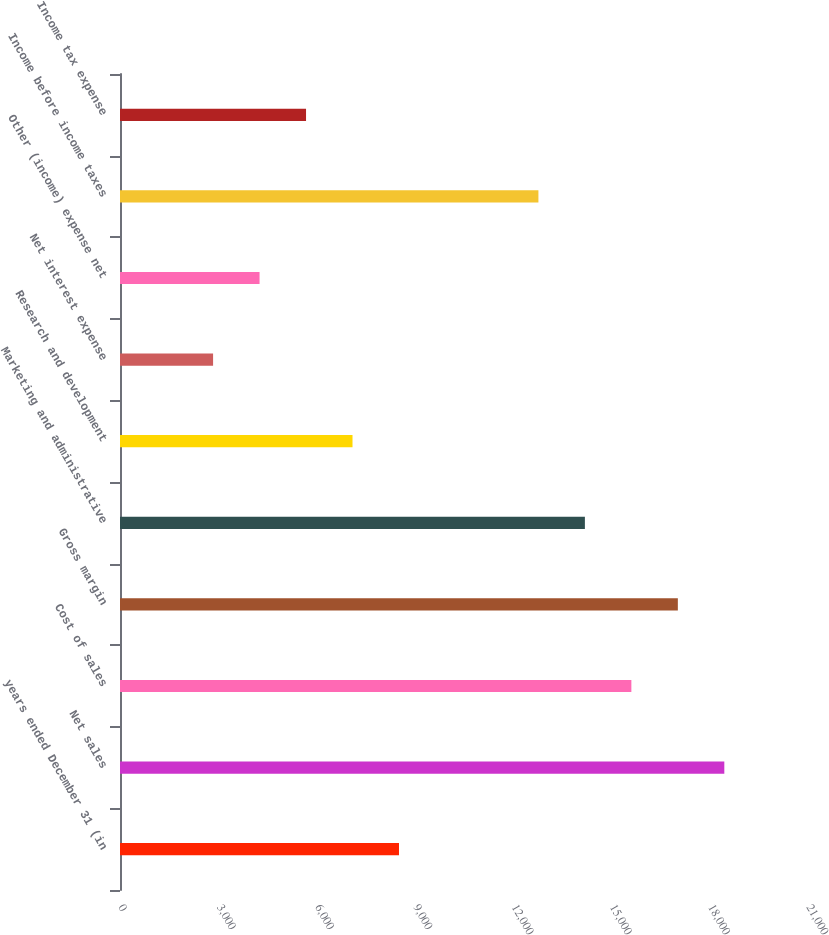Convert chart. <chart><loc_0><loc_0><loc_500><loc_500><bar_chart><fcel>years ended December 31 (in<fcel>Net sales<fcel>Cost of sales<fcel>Gross margin<fcel>Marketing and administrative<fcel>Research and development<fcel>Net interest expense<fcel>Other (income) expense net<fcel>Income before income taxes<fcel>Income tax expense<nl><fcel>8515.66<fcel>18445.7<fcel>15608.6<fcel>17027.1<fcel>14190<fcel>7097.08<fcel>2841.34<fcel>4259.92<fcel>12771.4<fcel>5678.5<nl></chart> 